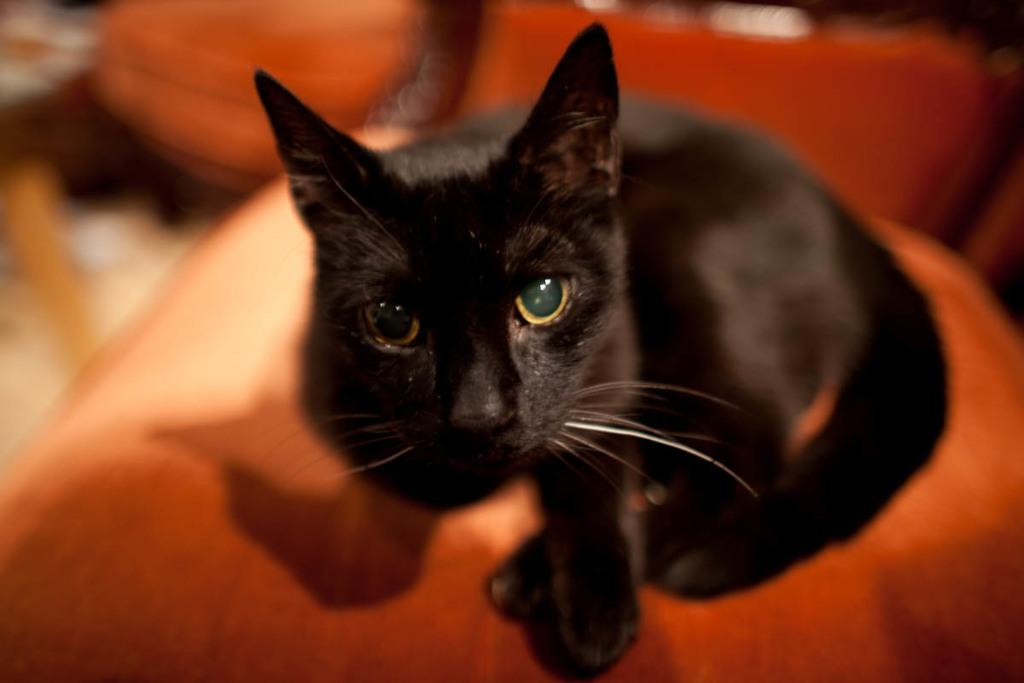What animal is present in the image? There is a cat in the image. What is the cat sitting on? The cat is sitting on an orange object. Can you describe the background of the image? The background of the image is blurred. How many bubbles are surrounding the cat in the image? There are no bubbles present in the image. What is the amount of yak in the image? There is no yak present in the image. 